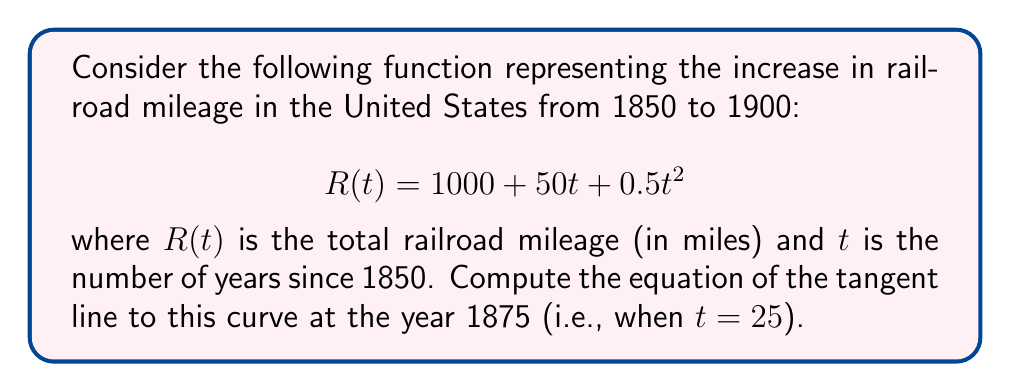Solve this math problem. To find the equation of the tangent line, we need to follow these steps:

1) The general equation of a tangent line is $y - y_1 = m(x - x_1)$, where $(x_1, y_1)$ is a point on the curve and $m$ is the slope of the tangent line at that point.

2) We need to find the coordinates of the point at $t = 25$ (year 1875):
   $x_1 = 25$
   $y_1 = R(25) = 1000 + 50(25) + 0.5(25)^2 = 1000 + 1250 + 312.5 = 2562.5$

3) To find the slope $m$, we need to calculate the derivative of $R(t)$:
   $$R'(t) = 50 + t$$

4) Evaluate the derivative at $t = 25$:
   $R'(25) = 50 + 25 = 75$

5) Now we have all the components to write the equation of the tangent line:
   $y - 2562.5 = 75(x - 25)$

6) Simplify:
   $y = 75x - 1875 + 2562.5$
   $y = 75x + 687.5$

This is the equation of the tangent line to the curve at the year 1875.
Answer: $y = 75x + 687.5$ 